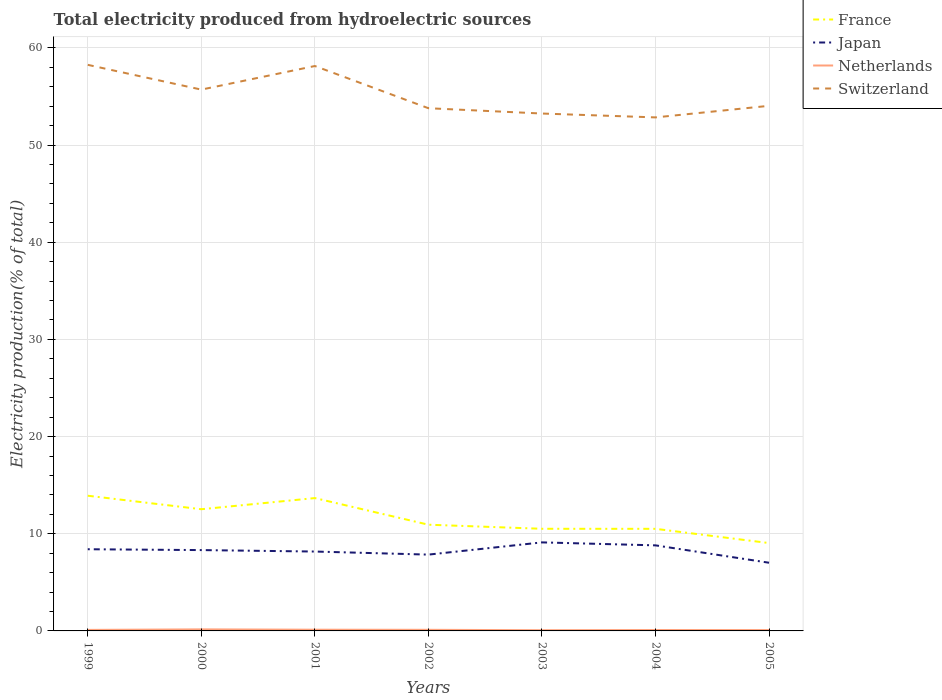Across all years, what is the maximum total electricity produced in Switzerland?
Give a very brief answer. 52.84. In which year was the total electricity produced in France maximum?
Your answer should be very brief. 2005. What is the total total electricity produced in Netherlands in the graph?
Your answer should be compact. 0.07. What is the difference between the highest and the second highest total electricity produced in Switzerland?
Keep it short and to the point. 5.41. What is the difference between the highest and the lowest total electricity produced in Netherlands?
Keep it short and to the point. 3. Is the total electricity produced in Switzerland strictly greater than the total electricity produced in France over the years?
Your response must be concise. No. How many lines are there?
Keep it short and to the point. 4. How many years are there in the graph?
Your response must be concise. 7. Are the values on the major ticks of Y-axis written in scientific E-notation?
Ensure brevity in your answer.  No. Does the graph contain any zero values?
Your response must be concise. No. Does the graph contain grids?
Offer a terse response. Yes. Where does the legend appear in the graph?
Offer a very short reply. Top right. How many legend labels are there?
Offer a very short reply. 4. How are the legend labels stacked?
Provide a short and direct response. Vertical. What is the title of the graph?
Offer a very short reply. Total electricity produced from hydroelectric sources. Does "Europe(developing only)" appear as one of the legend labels in the graph?
Offer a terse response. No. What is the label or title of the Y-axis?
Your response must be concise. Electricity production(% of total). What is the Electricity production(% of total) in France in 1999?
Ensure brevity in your answer.  13.91. What is the Electricity production(% of total) in Japan in 1999?
Provide a succinct answer. 8.41. What is the Electricity production(% of total) in Netherlands in 1999?
Offer a very short reply. 0.1. What is the Electricity production(% of total) in Switzerland in 1999?
Offer a terse response. 58.25. What is the Electricity production(% of total) of France in 2000?
Ensure brevity in your answer.  12.52. What is the Electricity production(% of total) of Japan in 2000?
Offer a terse response. 8.32. What is the Electricity production(% of total) in Netherlands in 2000?
Give a very brief answer. 0.16. What is the Electricity production(% of total) of Switzerland in 2000?
Offer a terse response. 55.7. What is the Electricity production(% of total) of France in 2001?
Ensure brevity in your answer.  13.67. What is the Electricity production(% of total) in Japan in 2001?
Provide a short and direct response. 8.17. What is the Electricity production(% of total) in Netherlands in 2001?
Provide a succinct answer. 0.12. What is the Electricity production(% of total) in Switzerland in 2001?
Your response must be concise. 58.13. What is the Electricity production(% of total) in France in 2002?
Your answer should be compact. 10.93. What is the Electricity production(% of total) of Japan in 2002?
Provide a short and direct response. 7.85. What is the Electricity production(% of total) of Netherlands in 2002?
Your response must be concise. 0.11. What is the Electricity production(% of total) in Switzerland in 2002?
Give a very brief answer. 53.79. What is the Electricity production(% of total) of France in 2003?
Your answer should be compact. 10.51. What is the Electricity production(% of total) in Japan in 2003?
Provide a succinct answer. 9.11. What is the Electricity production(% of total) of Netherlands in 2003?
Give a very brief answer. 0.07. What is the Electricity production(% of total) of Switzerland in 2003?
Provide a short and direct response. 53.24. What is the Electricity production(% of total) in France in 2004?
Make the answer very short. 10.51. What is the Electricity production(% of total) of Japan in 2004?
Your answer should be compact. 8.8. What is the Electricity production(% of total) of Netherlands in 2004?
Provide a short and direct response. 0.09. What is the Electricity production(% of total) of Switzerland in 2004?
Your answer should be very brief. 52.84. What is the Electricity production(% of total) in France in 2005?
Your response must be concise. 9.04. What is the Electricity production(% of total) of Japan in 2005?
Your answer should be very brief. 7.02. What is the Electricity production(% of total) in Netherlands in 2005?
Your response must be concise. 0.09. What is the Electricity production(% of total) of Switzerland in 2005?
Make the answer very short. 54.04. Across all years, what is the maximum Electricity production(% of total) in France?
Your answer should be compact. 13.91. Across all years, what is the maximum Electricity production(% of total) in Japan?
Make the answer very short. 9.11. Across all years, what is the maximum Electricity production(% of total) in Netherlands?
Provide a succinct answer. 0.16. Across all years, what is the maximum Electricity production(% of total) in Switzerland?
Your answer should be very brief. 58.25. Across all years, what is the minimum Electricity production(% of total) in France?
Ensure brevity in your answer.  9.04. Across all years, what is the minimum Electricity production(% of total) of Japan?
Keep it short and to the point. 7.02. Across all years, what is the minimum Electricity production(% of total) of Netherlands?
Your response must be concise. 0.07. Across all years, what is the minimum Electricity production(% of total) of Switzerland?
Offer a terse response. 52.84. What is the total Electricity production(% of total) in France in the graph?
Give a very brief answer. 81.09. What is the total Electricity production(% of total) of Japan in the graph?
Provide a short and direct response. 57.68. What is the total Electricity production(% of total) of Netherlands in the graph?
Offer a very short reply. 0.76. What is the total Electricity production(% of total) of Switzerland in the graph?
Provide a succinct answer. 386. What is the difference between the Electricity production(% of total) in France in 1999 and that in 2000?
Your answer should be compact. 1.39. What is the difference between the Electricity production(% of total) of Japan in 1999 and that in 2000?
Provide a short and direct response. 0.09. What is the difference between the Electricity production(% of total) of Netherlands in 1999 and that in 2000?
Make the answer very short. -0.05. What is the difference between the Electricity production(% of total) of Switzerland in 1999 and that in 2000?
Offer a terse response. 2.55. What is the difference between the Electricity production(% of total) of France in 1999 and that in 2001?
Provide a succinct answer. 0.24. What is the difference between the Electricity production(% of total) of Japan in 1999 and that in 2001?
Ensure brevity in your answer.  0.24. What is the difference between the Electricity production(% of total) of Netherlands in 1999 and that in 2001?
Provide a succinct answer. -0.02. What is the difference between the Electricity production(% of total) of Switzerland in 1999 and that in 2001?
Provide a short and direct response. 0.12. What is the difference between the Electricity production(% of total) in France in 1999 and that in 2002?
Provide a succinct answer. 2.98. What is the difference between the Electricity production(% of total) in Japan in 1999 and that in 2002?
Ensure brevity in your answer.  0.55. What is the difference between the Electricity production(% of total) of Netherlands in 1999 and that in 2002?
Ensure brevity in your answer.  -0.01. What is the difference between the Electricity production(% of total) of Switzerland in 1999 and that in 2002?
Your answer should be compact. 4.46. What is the difference between the Electricity production(% of total) in France in 1999 and that in 2003?
Make the answer very short. 3.4. What is the difference between the Electricity production(% of total) in Japan in 1999 and that in 2003?
Provide a succinct answer. -0.71. What is the difference between the Electricity production(% of total) of Netherlands in 1999 and that in 2003?
Make the answer very short. 0.03. What is the difference between the Electricity production(% of total) of Switzerland in 1999 and that in 2003?
Your answer should be compact. 5.01. What is the difference between the Electricity production(% of total) of France in 1999 and that in 2004?
Your answer should be very brief. 3.41. What is the difference between the Electricity production(% of total) of Japan in 1999 and that in 2004?
Offer a terse response. -0.4. What is the difference between the Electricity production(% of total) of Netherlands in 1999 and that in 2004?
Give a very brief answer. 0.01. What is the difference between the Electricity production(% of total) in Switzerland in 1999 and that in 2004?
Give a very brief answer. 5.41. What is the difference between the Electricity production(% of total) of France in 1999 and that in 2005?
Offer a very short reply. 4.87. What is the difference between the Electricity production(% of total) in Japan in 1999 and that in 2005?
Keep it short and to the point. 1.39. What is the difference between the Electricity production(% of total) of Netherlands in 1999 and that in 2005?
Offer a very short reply. 0.02. What is the difference between the Electricity production(% of total) of Switzerland in 1999 and that in 2005?
Give a very brief answer. 4.22. What is the difference between the Electricity production(% of total) in France in 2000 and that in 2001?
Your answer should be compact. -1.15. What is the difference between the Electricity production(% of total) in Japan in 2000 and that in 2001?
Your answer should be compact. 0.15. What is the difference between the Electricity production(% of total) in Netherlands in 2000 and that in 2001?
Your answer should be compact. 0.03. What is the difference between the Electricity production(% of total) in Switzerland in 2000 and that in 2001?
Ensure brevity in your answer.  -2.43. What is the difference between the Electricity production(% of total) of France in 2000 and that in 2002?
Your answer should be compact. 1.59. What is the difference between the Electricity production(% of total) in Japan in 2000 and that in 2002?
Offer a terse response. 0.46. What is the difference between the Electricity production(% of total) in Netherlands in 2000 and that in 2002?
Your answer should be compact. 0.04. What is the difference between the Electricity production(% of total) in Switzerland in 2000 and that in 2002?
Make the answer very short. 1.91. What is the difference between the Electricity production(% of total) in France in 2000 and that in 2003?
Keep it short and to the point. 2.01. What is the difference between the Electricity production(% of total) in Japan in 2000 and that in 2003?
Offer a very short reply. -0.79. What is the difference between the Electricity production(% of total) of Netherlands in 2000 and that in 2003?
Provide a succinct answer. 0.08. What is the difference between the Electricity production(% of total) in Switzerland in 2000 and that in 2003?
Your response must be concise. 2.46. What is the difference between the Electricity production(% of total) in France in 2000 and that in 2004?
Keep it short and to the point. 2.02. What is the difference between the Electricity production(% of total) in Japan in 2000 and that in 2004?
Provide a short and direct response. -0.49. What is the difference between the Electricity production(% of total) in Netherlands in 2000 and that in 2004?
Your response must be concise. 0.07. What is the difference between the Electricity production(% of total) of Switzerland in 2000 and that in 2004?
Make the answer very short. 2.86. What is the difference between the Electricity production(% of total) of France in 2000 and that in 2005?
Provide a short and direct response. 3.48. What is the difference between the Electricity production(% of total) in Japan in 2000 and that in 2005?
Your response must be concise. 1.3. What is the difference between the Electricity production(% of total) of Netherlands in 2000 and that in 2005?
Ensure brevity in your answer.  0.07. What is the difference between the Electricity production(% of total) of Switzerland in 2000 and that in 2005?
Offer a terse response. 1.67. What is the difference between the Electricity production(% of total) in France in 2001 and that in 2002?
Make the answer very short. 2.74. What is the difference between the Electricity production(% of total) in Japan in 2001 and that in 2002?
Offer a terse response. 0.32. What is the difference between the Electricity production(% of total) in Netherlands in 2001 and that in 2002?
Make the answer very short. 0.01. What is the difference between the Electricity production(% of total) of Switzerland in 2001 and that in 2002?
Your answer should be compact. 4.34. What is the difference between the Electricity production(% of total) of France in 2001 and that in 2003?
Make the answer very short. 3.16. What is the difference between the Electricity production(% of total) of Japan in 2001 and that in 2003?
Offer a terse response. -0.94. What is the difference between the Electricity production(% of total) in Netherlands in 2001 and that in 2003?
Provide a short and direct response. 0.05. What is the difference between the Electricity production(% of total) in Switzerland in 2001 and that in 2003?
Keep it short and to the point. 4.89. What is the difference between the Electricity production(% of total) of France in 2001 and that in 2004?
Keep it short and to the point. 3.16. What is the difference between the Electricity production(% of total) in Japan in 2001 and that in 2004?
Your answer should be very brief. -0.64. What is the difference between the Electricity production(% of total) in Netherlands in 2001 and that in 2004?
Offer a terse response. 0.03. What is the difference between the Electricity production(% of total) of Switzerland in 2001 and that in 2004?
Ensure brevity in your answer.  5.29. What is the difference between the Electricity production(% of total) of France in 2001 and that in 2005?
Give a very brief answer. 4.63. What is the difference between the Electricity production(% of total) of Japan in 2001 and that in 2005?
Offer a very short reply. 1.15. What is the difference between the Electricity production(% of total) in Netherlands in 2001 and that in 2005?
Your answer should be compact. 0.04. What is the difference between the Electricity production(% of total) in Switzerland in 2001 and that in 2005?
Your response must be concise. 4.1. What is the difference between the Electricity production(% of total) in France in 2002 and that in 2003?
Ensure brevity in your answer.  0.42. What is the difference between the Electricity production(% of total) in Japan in 2002 and that in 2003?
Offer a terse response. -1.26. What is the difference between the Electricity production(% of total) in Netherlands in 2002 and that in 2003?
Provide a short and direct response. 0.04. What is the difference between the Electricity production(% of total) in Switzerland in 2002 and that in 2003?
Your answer should be very brief. 0.55. What is the difference between the Electricity production(% of total) of France in 2002 and that in 2004?
Offer a terse response. 0.42. What is the difference between the Electricity production(% of total) of Japan in 2002 and that in 2004?
Provide a short and direct response. -0.95. What is the difference between the Electricity production(% of total) in Netherlands in 2002 and that in 2004?
Make the answer very short. 0.02. What is the difference between the Electricity production(% of total) of Switzerland in 2002 and that in 2004?
Offer a terse response. 0.95. What is the difference between the Electricity production(% of total) in France in 2002 and that in 2005?
Ensure brevity in your answer.  1.89. What is the difference between the Electricity production(% of total) of Japan in 2002 and that in 2005?
Provide a succinct answer. 0.84. What is the difference between the Electricity production(% of total) in Netherlands in 2002 and that in 2005?
Make the answer very short. 0.03. What is the difference between the Electricity production(% of total) in Switzerland in 2002 and that in 2005?
Offer a terse response. -0.25. What is the difference between the Electricity production(% of total) of France in 2003 and that in 2004?
Give a very brief answer. 0. What is the difference between the Electricity production(% of total) in Japan in 2003 and that in 2004?
Ensure brevity in your answer.  0.31. What is the difference between the Electricity production(% of total) in Netherlands in 2003 and that in 2004?
Keep it short and to the point. -0.02. What is the difference between the Electricity production(% of total) in Switzerland in 2003 and that in 2004?
Ensure brevity in your answer.  0.4. What is the difference between the Electricity production(% of total) in France in 2003 and that in 2005?
Ensure brevity in your answer.  1.47. What is the difference between the Electricity production(% of total) in Japan in 2003 and that in 2005?
Provide a short and direct response. 2.09. What is the difference between the Electricity production(% of total) of Netherlands in 2003 and that in 2005?
Offer a terse response. -0.01. What is the difference between the Electricity production(% of total) in Switzerland in 2003 and that in 2005?
Keep it short and to the point. -0.79. What is the difference between the Electricity production(% of total) in France in 2004 and that in 2005?
Your response must be concise. 1.47. What is the difference between the Electricity production(% of total) in Japan in 2004 and that in 2005?
Provide a succinct answer. 1.79. What is the difference between the Electricity production(% of total) of Netherlands in 2004 and that in 2005?
Provide a short and direct response. 0. What is the difference between the Electricity production(% of total) in Switzerland in 2004 and that in 2005?
Provide a short and direct response. -1.19. What is the difference between the Electricity production(% of total) in France in 1999 and the Electricity production(% of total) in Japan in 2000?
Provide a short and direct response. 5.59. What is the difference between the Electricity production(% of total) of France in 1999 and the Electricity production(% of total) of Netherlands in 2000?
Ensure brevity in your answer.  13.75. What is the difference between the Electricity production(% of total) of France in 1999 and the Electricity production(% of total) of Switzerland in 2000?
Ensure brevity in your answer.  -41.79. What is the difference between the Electricity production(% of total) in Japan in 1999 and the Electricity production(% of total) in Netherlands in 2000?
Offer a very short reply. 8.25. What is the difference between the Electricity production(% of total) in Japan in 1999 and the Electricity production(% of total) in Switzerland in 2000?
Offer a very short reply. -47.3. What is the difference between the Electricity production(% of total) in Netherlands in 1999 and the Electricity production(% of total) in Switzerland in 2000?
Keep it short and to the point. -55.6. What is the difference between the Electricity production(% of total) in France in 1999 and the Electricity production(% of total) in Japan in 2001?
Your answer should be compact. 5.74. What is the difference between the Electricity production(% of total) in France in 1999 and the Electricity production(% of total) in Netherlands in 2001?
Ensure brevity in your answer.  13.79. What is the difference between the Electricity production(% of total) in France in 1999 and the Electricity production(% of total) in Switzerland in 2001?
Provide a short and direct response. -44.22. What is the difference between the Electricity production(% of total) of Japan in 1999 and the Electricity production(% of total) of Netherlands in 2001?
Your answer should be very brief. 8.28. What is the difference between the Electricity production(% of total) of Japan in 1999 and the Electricity production(% of total) of Switzerland in 2001?
Make the answer very short. -49.73. What is the difference between the Electricity production(% of total) of Netherlands in 1999 and the Electricity production(% of total) of Switzerland in 2001?
Offer a terse response. -58.03. What is the difference between the Electricity production(% of total) of France in 1999 and the Electricity production(% of total) of Japan in 2002?
Provide a short and direct response. 6.06. What is the difference between the Electricity production(% of total) in France in 1999 and the Electricity production(% of total) in Netherlands in 2002?
Make the answer very short. 13.8. What is the difference between the Electricity production(% of total) of France in 1999 and the Electricity production(% of total) of Switzerland in 2002?
Your response must be concise. -39.88. What is the difference between the Electricity production(% of total) of Japan in 1999 and the Electricity production(% of total) of Netherlands in 2002?
Make the answer very short. 8.29. What is the difference between the Electricity production(% of total) of Japan in 1999 and the Electricity production(% of total) of Switzerland in 2002?
Your answer should be compact. -45.38. What is the difference between the Electricity production(% of total) in Netherlands in 1999 and the Electricity production(% of total) in Switzerland in 2002?
Give a very brief answer. -53.69. What is the difference between the Electricity production(% of total) of France in 1999 and the Electricity production(% of total) of Japan in 2003?
Offer a terse response. 4.8. What is the difference between the Electricity production(% of total) in France in 1999 and the Electricity production(% of total) in Netherlands in 2003?
Keep it short and to the point. 13.84. What is the difference between the Electricity production(% of total) in France in 1999 and the Electricity production(% of total) in Switzerland in 2003?
Offer a terse response. -39.33. What is the difference between the Electricity production(% of total) of Japan in 1999 and the Electricity production(% of total) of Netherlands in 2003?
Give a very brief answer. 8.33. What is the difference between the Electricity production(% of total) of Japan in 1999 and the Electricity production(% of total) of Switzerland in 2003?
Ensure brevity in your answer.  -44.84. What is the difference between the Electricity production(% of total) in Netherlands in 1999 and the Electricity production(% of total) in Switzerland in 2003?
Offer a very short reply. -53.14. What is the difference between the Electricity production(% of total) of France in 1999 and the Electricity production(% of total) of Japan in 2004?
Your answer should be compact. 5.11. What is the difference between the Electricity production(% of total) in France in 1999 and the Electricity production(% of total) in Netherlands in 2004?
Give a very brief answer. 13.82. What is the difference between the Electricity production(% of total) in France in 1999 and the Electricity production(% of total) in Switzerland in 2004?
Give a very brief answer. -38.93. What is the difference between the Electricity production(% of total) in Japan in 1999 and the Electricity production(% of total) in Netherlands in 2004?
Keep it short and to the point. 8.31. What is the difference between the Electricity production(% of total) of Japan in 1999 and the Electricity production(% of total) of Switzerland in 2004?
Provide a short and direct response. -44.44. What is the difference between the Electricity production(% of total) in Netherlands in 1999 and the Electricity production(% of total) in Switzerland in 2004?
Your answer should be very brief. -52.74. What is the difference between the Electricity production(% of total) of France in 1999 and the Electricity production(% of total) of Japan in 2005?
Keep it short and to the point. 6.9. What is the difference between the Electricity production(% of total) of France in 1999 and the Electricity production(% of total) of Netherlands in 2005?
Provide a succinct answer. 13.82. What is the difference between the Electricity production(% of total) of France in 1999 and the Electricity production(% of total) of Switzerland in 2005?
Provide a short and direct response. -40.12. What is the difference between the Electricity production(% of total) in Japan in 1999 and the Electricity production(% of total) in Netherlands in 2005?
Keep it short and to the point. 8.32. What is the difference between the Electricity production(% of total) of Japan in 1999 and the Electricity production(% of total) of Switzerland in 2005?
Offer a very short reply. -45.63. What is the difference between the Electricity production(% of total) of Netherlands in 1999 and the Electricity production(% of total) of Switzerland in 2005?
Ensure brevity in your answer.  -53.93. What is the difference between the Electricity production(% of total) of France in 2000 and the Electricity production(% of total) of Japan in 2001?
Ensure brevity in your answer.  4.35. What is the difference between the Electricity production(% of total) of France in 2000 and the Electricity production(% of total) of Netherlands in 2001?
Ensure brevity in your answer.  12.4. What is the difference between the Electricity production(% of total) of France in 2000 and the Electricity production(% of total) of Switzerland in 2001?
Offer a terse response. -45.61. What is the difference between the Electricity production(% of total) in Japan in 2000 and the Electricity production(% of total) in Netherlands in 2001?
Provide a succinct answer. 8.19. What is the difference between the Electricity production(% of total) of Japan in 2000 and the Electricity production(% of total) of Switzerland in 2001?
Keep it short and to the point. -49.81. What is the difference between the Electricity production(% of total) of Netherlands in 2000 and the Electricity production(% of total) of Switzerland in 2001?
Offer a terse response. -57.97. What is the difference between the Electricity production(% of total) in France in 2000 and the Electricity production(% of total) in Japan in 2002?
Your answer should be very brief. 4.67. What is the difference between the Electricity production(% of total) in France in 2000 and the Electricity production(% of total) in Netherlands in 2002?
Provide a short and direct response. 12.41. What is the difference between the Electricity production(% of total) of France in 2000 and the Electricity production(% of total) of Switzerland in 2002?
Provide a succinct answer. -41.27. What is the difference between the Electricity production(% of total) of Japan in 2000 and the Electricity production(% of total) of Netherlands in 2002?
Your response must be concise. 8.2. What is the difference between the Electricity production(% of total) in Japan in 2000 and the Electricity production(% of total) in Switzerland in 2002?
Keep it short and to the point. -45.47. What is the difference between the Electricity production(% of total) in Netherlands in 2000 and the Electricity production(% of total) in Switzerland in 2002?
Make the answer very short. -53.63. What is the difference between the Electricity production(% of total) in France in 2000 and the Electricity production(% of total) in Japan in 2003?
Ensure brevity in your answer.  3.41. What is the difference between the Electricity production(% of total) in France in 2000 and the Electricity production(% of total) in Netherlands in 2003?
Keep it short and to the point. 12.45. What is the difference between the Electricity production(% of total) of France in 2000 and the Electricity production(% of total) of Switzerland in 2003?
Your response must be concise. -40.72. What is the difference between the Electricity production(% of total) in Japan in 2000 and the Electricity production(% of total) in Netherlands in 2003?
Ensure brevity in your answer.  8.24. What is the difference between the Electricity production(% of total) in Japan in 2000 and the Electricity production(% of total) in Switzerland in 2003?
Make the answer very short. -44.92. What is the difference between the Electricity production(% of total) of Netherlands in 2000 and the Electricity production(% of total) of Switzerland in 2003?
Your answer should be compact. -53.08. What is the difference between the Electricity production(% of total) in France in 2000 and the Electricity production(% of total) in Japan in 2004?
Ensure brevity in your answer.  3.72. What is the difference between the Electricity production(% of total) in France in 2000 and the Electricity production(% of total) in Netherlands in 2004?
Your answer should be compact. 12.43. What is the difference between the Electricity production(% of total) of France in 2000 and the Electricity production(% of total) of Switzerland in 2004?
Your answer should be very brief. -40.32. What is the difference between the Electricity production(% of total) of Japan in 2000 and the Electricity production(% of total) of Netherlands in 2004?
Offer a terse response. 8.23. What is the difference between the Electricity production(% of total) in Japan in 2000 and the Electricity production(% of total) in Switzerland in 2004?
Your answer should be compact. -44.53. What is the difference between the Electricity production(% of total) of Netherlands in 2000 and the Electricity production(% of total) of Switzerland in 2004?
Make the answer very short. -52.69. What is the difference between the Electricity production(% of total) of France in 2000 and the Electricity production(% of total) of Japan in 2005?
Provide a succinct answer. 5.51. What is the difference between the Electricity production(% of total) in France in 2000 and the Electricity production(% of total) in Netherlands in 2005?
Provide a succinct answer. 12.44. What is the difference between the Electricity production(% of total) of France in 2000 and the Electricity production(% of total) of Switzerland in 2005?
Your answer should be very brief. -41.51. What is the difference between the Electricity production(% of total) in Japan in 2000 and the Electricity production(% of total) in Netherlands in 2005?
Your response must be concise. 8.23. What is the difference between the Electricity production(% of total) in Japan in 2000 and the Electricity production(% of total) in Switzerland in 2005?
Keep it short and to the point. -45.72. What is the difference between the Electricity production(% of total) in Netherlands in 2000 and the Electricity production(% of total) in Switzerland in 2005?
Provide a succinct answer. -53.88. What is the difference between the Electricity production(% of total) of France in 2001 and the Electricity production(% of total) of Japan in 2002?
Keep it short and to the point. 5.82. What is the difference between the Electricity production(% of total) of France in 2001 and the Electricity production(% of total) of Netherlands in 2002?
Make the answer very short. 13.56. What is the difference between the Electricity production(% of total) in France in 2001 and the Electricity production(% of total) in Switzerland in 2002?
Give a very brief answer. -40.12. What is the difference between the Electricity production(% of total) in Japan in 2001 and the Electricity production(% of total) in Netherlands in 2002?
Offer a very short reply. 8.05. What is the difference between the Electricity production(% of total) of Japan in 2001 and the Electricity production(% of total) of Switzerland in 2002?
Your answer should be compact. -45.62. What is the difference between the Electricity production(% of total) of Netherlands in 2001 and the Electricity production(% of total) of Switzerland in 2002?
Provide a succinct answer. -53.66. What is the difference between the Electricity production(% of total) in France in 2001 and the Electricity production(% of total) in Japan in 2003?
Your answer should be compact. 4.56. What is the difference between the Electricity production(% of total) of France in 2001 and the Electricity production(% of total) of Netherlands in 2003?
Ensure brevity in your answer.  13.6. What is the difference between the Electricity production(% of total) in France in 2001 and the Electricity production(% of total) in Switzerland in 2003?
Your answer should be very brief. -39.57. What is the difference between the Electricity production(% of total) of Japan in 2001 and the Electricity production(% of total) of Netherlands in 2003?
Keep it short and to the point. 8.09. What is the difference between the Electricity production(% of total) of Japan in 2001 and the Electricity production(% of total) of Switzerland in 2003?
Make the answer very short. -45.07. What is the difference between the Electricity production(% of total) in Netherlands in 2001 and the Electricity production(% of total) in Switzerland in 2003?
Offer a very short reply. -53.12. What is the difference between the Electricity production(% of total) in France in 2001 and the Electricity production(% of total) in Japan in 2004?
Give a very brief answer. 4.87. What is the difference between the Electricity production(% of total) in France in 2001 and the Electricity production(% of total) in Netherlands in 2004?
Your response must be concise. 13.58. What is the difference between the Electricity production(% of total) in France in 2001 and the Electricity production(% of total) in Switzerland in 2004?
Your answer should be very brief. -39.17. What is the difference between the Electricity production(% of total) in Japan in 2001 and the Electricity production(% of total) in Netherlands in 2004?
Offer a very short reply. 8.08. What is the difference between the Electricity production(% of total) of Japan in 2001 and the Electricity production(% of total) of Switzerland in 2004?
Keep it short and to the point. -44.68. What is the difference between the Electricity production(% of total) of Netherlands in 2001 and the Electricity production(% of total) of Switzerland in 2004?
Give a very brief answer. -52.72. What is the difference between the Electricity production(% of total) in France in 2001 and the Electricity production(% of total) in Japan in 2005?
Ensure brevity in your answer.  6.65. What is the difference between the Electricity production(% of total) of France in 2001 and the Electricity production(% of total) of Netherlands in 2005?
Ensure brevity in your answer.  13.58. What is the difference between the Electricity production(% of total) in France in 2001 and the Electricity production(% of total) in Switzerland in 2005?
Your answer should be very brief. -40.37. What is the difference between the Electricity production(% of total) in Japan in 2001 and the Electricity production(% of total) in Netherlands in 2005?
Provide a succinct answer. 8.08. What is the difference between the Electricity production(% of total) of Japan in 2001 and the Electricity production(% of total) of Switzerland in 2005?
Your answer should be very brief. -45.87. What is the difference between the Electricity production(% of total) in Netherlands in 2001 and the Electricity production(% of total) in Switzerland in 2005?
Provide a succinct answer. -53.91. What is the difference between the Electricity production(% of total) of France in 2002 and the Electricity production(% of total) of Japan in 2003?
Give a very brief answer. 1.82. What is the difference between the Electricity production(% of total) of France in 2002 and the Electricity production(% of total) of Netherlands in 2003?
Provide a short and direct response. 10.86. What is the difference between the Electricity production(% of total) in France in 2002 and the Electricity production(% of total) in Switzerland in 2003?
Your response must be concise. -42.31. What is the difference between the Electricity production(% of total) in Japan in 2002 and the Electricity production(% of total) in Netherlands in 2003?
Offer a terse response. 7.78. What is the difference between the Electricity production(% of total) of Japan in 2002 and the Electricity production(% of total) of Switzerland in 2003?
Keep it short and to the point. -45.39. What is the difference between the Electricity production(% of total) of Netherlands in 2002 and the Electricity production(% of total) of Switzerland in 2003?
Your response must be concise. -53.13. What is the difference between the Electricity production(% of total) of France in 2002 and the Electricity production(% of total) of Japan in 2004?
Give a very brief answer. 2.13. What is the difference between the Electricity production(% of total) of France in 2002 and the Electricity production(% of total) of Netherlands in 2004?
Offer a very short reply. 10.84. What is the difference between the Electricity production(% of total) in France in 2002 and the Electricity production(% of total) in Switzerland in 2004?
Your response must be concise. -41.91. What is the difference between the Electricity production(% of total) of Japan in 2002 and the Electricity production(% of total) of Netherlands in 2004?
Offer a very short reply. 7.76. What is the difference between the Electricity production(% of total) in Japan in 2002 and the Electricity production(% of total) in Switzerland in 2004?
Your answer should be compact. -44.99. What is the difference between the Electricity production(% of total) of Netherlands in 2002 and the Electricity production(% of total) of Switzerland in 2004?
Provide a short and direct response. -52.73. What is the difference between the Electricity production(% of total) in France in 2002 and the Electricity production(% of total) in Japan in 2005?
Make the answer very short. 3.91. What is the difference between the Electricity production(% of total) in France in 2002 and the Electricity production(% of total) in Netherlands in 2005?
Give a very brief answer. 10.84. What is the difference between the Electricity production(% of total) of France in 2002 and the Electricity production(% of total) of Switzerland in 2005?
Your answer should be compact. -43.11. What is the difference between the Electricity production(% of total) in Japan in 2002 and the Electricity production(% of total) in Netherlands in 2005?
Provide a succinct answer. 7.77. What is the difference between the Electricity production(% of total) in Japan in 2002 and the Electricity production(% of total) in Switzerland in 2005?
Make the answer very short. -46.18. What is the difference between the Electricity production(% of total) in Netherlands in 2002 and the Electricity production(% of total) in Switzerland in 2005?
Your answer should be very brief. -53.92. What is the difference between the Electricity production(% of total) in France in 2003 and the Electricity production(% of total) in Japan in 2004?
Provide a succinct answer. 1.71. What is the difference between the Electricity production(% of total) of France in 2003 and the Electricity production(% of total) of Netherlands in 2004?
Keep it short and to the point. 10.42. What is the difference between the Electricity production(% of total) in France in 2003 and the Electricity production(% of total) in Switzerland in 2004?
Make the answer very short. -42.33. What is the difference between the Electricity production(% of total) of Japan in 2003 and the Electricity production(% of total) of Netherlands in 2004?
Provide a succinct answer. 9.02. What is the difference between the Electricity production(% of total) of Japan in 2003 and the Electricity production(% of total) of Switzerland in 2004?
Provide a succinct answer. -43.73. What is the difference between the Electricity production(% of total) of Netherlands in 2003 and the Electricity production(% of total) of Switzerland in 2004?
Make the answer very short. -52.77. What is the difference between the Electricity production(% of total) in France in 2003 and the Electricity production(% of total) in Japan in 2005?
Offer a terse response. 3.49. What is the difference between the Electricity production(% of total) in France in 2003 and the Electricity production(% of total) in Netherlands in 2005?
Your answer should be compact. 10.42. What is the difference between the Electricity production(% of total) of France in 2003 and the Electricity production(% of total) of Switzerland in 2005?
Provide a succinct answer. -43.53. What is the difference between the Electricity production(% of total) in Japan in 2003 and the Electricity production(% of total) in Netherlands in 2005?
Offer a terse response. 9.02. What is the difference between the Electricity production(% of total) in Japan in 2003 and the Electricity production(% of total) in Switzerland in 2005?
Offer a terse response. -44.93. What is the difference between the Electricity production(% of total) in Netherlands in 2003 and the Electricity production(% of total) in Switzerland in 2005?
Offer a very short reply. -53.96. What is the difference between the Electricity production(% of total) of France in 2004 and the Electricity production(% of total) of Japan in 2005?
Provide a succinct answer. 3.49. What is the difference between the Electricity production(% of total) in France in 2004 and the Electricity production(% of total) in Netherlands in 2005?
Your response must be concise. 10.42. What is the difference between the Electricity production(% of total) in France in 2004 and the Electricity production(% of total) in Switzerland in 2005?
Give a very brief answer. -43.53. What is the difference between the Electricity production(% of total) of Japan in 2004 and the Electricity production(% of total) of Netherlands in 2005?
Your response must be concise. 8.72. What is the difference between the Electricity production(% of total) in Japan in 2004 and the Electricity production(% of total) in Switzerland in 2005?
Give a very brief answer. -45.23. What is the difference between the Electricity production(% of total) of Netherlands in 2004 and the Electricity production(% of total) of Switzerland in 2005?
Keep it short and to the point. -53.94. What is the average Electricity production(% of total) in France per year?
Make the answer very short. 11.58. What is the average Electricity production(% of total) in Japan per year?
Make the answer very short. 8.24. What is the average Electricity production(% of total) in Netherlands per year?
Your response must be concise. 0.11. What is the average Electricity production(% of total) in Switzerland per year?
Give a very brief answer. 55.14. In the year 1999, what is the difference between the Electricity production(% of total) of France and Electricity production(% of total) of Japan?
Offer a very short reply. 5.51. In the year 1999, what is the difference between the Electricity production(% of total) of France and Electricity production(% of total) of Netherlands?
Ensure brevity in your answer.  13.81. In the year 1999, what is the difference between the Electricity production(% of total) of France and Electricity production(% of total) of Switzerland?
Provide a succinct answer. -44.34. In the year 1999, what is the difference between the Electricity production(% of total) in Japan and Electricity production(% of total) in Netherlands?
Provide a succinct answer. 8.3. In the year 1999, what is the difference between the Electricity production(% of total) in Japan and Electricity production(% of total) in Switzerland?
Offer a very short reply. -49.85. In the year 1999, what is the difference between the Electricity production(% of total) in Netherlands and Electricity production(% of total) in Switzerland?
Keep it short and to the point. -58.15. In the year 2000, what is the difference between the Electricity production(% of total) of France and Electricity production(% of total) of Japan?
Give a very brief answer. 4.21. In the year 2000, what is the difference between the Electricity production(% of total) of France and Electricity production(% of total) of Netherlands?
Your response must be concise. 12.36. In the year 2000, what is the difference between the Electricity production(% of total) in France and Electricity production(% of total) in Switzerland?
Your response must be concise. -43.18. In the year 2000, what is the difference between the Electricity production(% of total) in Japan and Electricity production(% of total) in Netherlands?
Your answer should be compact. 8.16. In the year 2000, what is the difference between the Electricity production(% of total) in Japan and Electricity production(% of total) in Switzerland?
Offer a terse response. -47.39. In the year 2000, what is the difference between the Electricity production(% of total) of Netherlands and Electricity production(% of total) of Switzerland?
Keep it short and to the point. -55.55. In the year 2001, what is the difference between the Electricity production(% of total) of France and Electricity production(% of total) of Japan?
Keep it short and to the point. 5.5. In the year 2001, what is the difference between the Electricity production(% of total) of France and Electricity production(% of total) of Netherlands?
Offer a terse response. 13.55. In the year 2001, what is the difference between the Electricity production(% of total) in France and Electricity production(% of total) in Switzerland?
Your answer should be very brief. -44.46. In the year 2001, what is the difference between the Electricity production(% of total) in Japan and Electricity production(% of total) in Netherlands?
Give a very brief answer. 8.04. In the year 2001, what is the difference between the Electricity production(% of total) in Japan and Electricity production(% of total) in Switzerland?
Make the answer very short. -49.96. In the year 2001, what is the difference between the Electricity production(% of total) in Netherlands and Electricity production(% of total) in Switzerland?
Make the answer very short. -58.01. In the year 2002, what is the difference between the Electricity production(% of total) in France and Electricity production(% of total) in Japan?
Your answer should be very brief. 3.08. In the year 2002, what is the difference between the Electricity production(% of total) in France and Electricity production(% of total) in Netherlands?
Provide a succinct answer. 10.82. In the year 2002, what is the difference between the Electricity production(% of total) in France and Electricity production(% of total) in Switzerland?
Make the answer very short. -42.86. In the year 2002, what is the difference between the Electricity production(% of total) in Japan and Electricity production(% of total) in Netherlands?
Keep it short and to the point. 7.74. In the year 2002, what is the difference between the Electricity production(% of total) in Japan and Electricity production(% of total) in Switzerland?
Provide a succinct answer. -45.94. In the year 2002, what is the difference between the Electricity production(% of total) of Netherlands and Electricity production(% of total) of Switzerland?
Offer a very short reply. -53.68. In the year 2003, what is the difference between the Electricity production(% of total) in France and Electricity production(% of total) in Netherlands?
Offer a terse response. 10.44. In the year 2003, what is the difference between the Electricity production(% of total) in France and Electricity production(% of total) in Switzerland?
Make the answer very short. -42.73. In the year 2003, what is the difference between the Electricity production(% of total) of Japan and Electricity production(% of total) of Netherlands?
Offer a very short reply. 9.04. In the year 2003, what is the difference between the Electricity production(% of total) of Japan and Electricity production(% of total) of Switzerland?
Make the answer very short. -44.13. In the year 2003, what is the difference between the Electricity production(% of total) of Netherlands and Electricity production(% of total) of Switzerland?
Provide a short and direct response. -53.17. In the year 2004, what is the difference between the Electricity production(% of total) of France and Electricity production(% of total) of Japan?
Your response must be concise. 1.7. In the year 2004, what is the difference between the Electricity production(% of total) in France and Electricity production(% of total) in Netherlands?
Your answer should be compact. 10.41. In the year 2004, what is the difference between the Electricity production(% of total) of France and Electricity production(% of total) of Switzerland?
Make the answer very short. -42.34. In the year 2004, what is the difference between the Electricity production(% of total) in Japan and Electricity production(% of total) in Netherlands?
Keep it short and to the point. 8.71. In the year 2004, what is the difference between the Electricity production(% of total) in Japan and Electricity production(% of total) in Switzerland?
Keep it short and to the point. -44.04. In the year 2004, what is the difference between the Electricity production(% of total) of Netherlands and Electricity production(% of total) of Switzerland?
Offer a terse response. -52.75. In the year 2005, what is the difference between the Electricity production(% of total) of France and Electricity production(% of total) of Japan?
Provide a short and direct response. 2.03. In the year 2005, what is the difference between the Electricity production(% of total) of France and Electricity production(% of total) of Netherlands?
Give a very brief answer. 8.95. In the year 2005, what is the difference between the Electricity production(% of total) of France and Electricity production(% of total) of Switzerland?
Make the answer very short. -45. In the year 2005, what is the difference between the Electricity production(% of total) of Japan and Electricity production(% of total) of Netherlands?
Keep it short and to the point. 6.93. In the year 2005, what is the difference between the Electricity production(% of total) in Japan and Electricity production(% of total) in Switzerland?
Your answer should be compact. -47.02. In the year 2005, what is the difference between the Electricity production(% of total) in Netherlands and Electricity production(% of total) in Switzerland?
Provide a succinct answer. -53.95. What is the ratio of the Electricity production(% of total) in France in 1999 to that in 2000?
Provide a short and direct response. 1.11. What is the ratio of the Electricity production(% of total) of Japan in 1999 to that in 2000?
Offer a very short reply. 1.01. What is the ratio of the Electricity production(% of total) of Netherlands in 1999 to that in 2000?
Your answer should be very brief. 0.66. What is the ratio of the Electricity production(% of total) in Switzerland in 1999 to that in 2000?
Ensure brevity in your answer.  1.05. What is the ratio of the Electricity production(% of total) in France in 1999 to that in 2001?
Give a very brief answer. 1.02. What is the ratio of the Electricity production(% of total) in Japan in 1999 to that in 2001?
Make the answer very short. 1.03. What is the ratio of the Electricity production(% of total) in Netherlands in 1999 to that in 2001?
Ensure brevity in your answer.  0.83. What is the ratio of the Electricity production(% of total) of Switzerland in 1999 to that in 2001?
Provide a short and direct response. 1. What is the ratio of the Electricity production(% of total) of France in 1999 to that in 2002?
Provide a short and direct response. 1.27. What is the ratio of the Electricity production(% of total) in Japan in 1999 to that in 2002?
Your answer should be very brief. 1.07. What is the ratio of the Electricity production(% of total) in Netherlands in 1999 to that in 2002?
Keep it short and to the point. 0.91. What is the ratio of the Electricity production(% of total) in Switzerland in 1999 to that in 2002?
Offer a very short reply. 1.08. What is the ratio of the Electricity production(% of total) in France in 1999 to that in 2003?
Provide a short and direct response. 1.32. What is the ratio of the Electricity production(% of total) in Japan in 1999 to that in 2003?
Your answer should be compact. 0.92. What is the ratio of the Electricity production(% of total) of Netherlands in 1999 to that in 2003?
Your response must be concise. 1.4. What is the ratio of the Electricity production(% of total) of Switzerland in 1999 to that in 2003?
Provide a short and direct response. 1.09. What is the ratio of the Electricity production(% of total) of France in 1999 to that in 2004?
Offer a terse response. 1.32. What is the ratio of the Electricity production(% of total) in Japan in 1999 to that in 2004?
Provide a short and direct response. 0.95. What is the ratio of the Electricity production(% of total) in Netherlands in 1999 to that in 2004?
Ensure brevity in your answer.  1.12. What is the ratio of the Electricity production(% of total) in Switzerland in 1999 to that in 2004?
Make the answer very short. 1.1. What is the ratio of the Electricity production(% of total) in France in 1999 to that in 2005?
Offer a terse response. 1.54. What is the ratio of the Electricity production(% of total) in Japan in 1999 to that in 2005?
Provide a short and direct response. 1.2. What is the ratio of the Electricity production(% of total) of Netherlands in 1999 to that in 2005?
Keep it short and to the point. 1.18. What is the ratio of the Electricity production(% of total) in Switzerland in 1999 to that in 2005?
Your answer should be compact. 1.08. What is the ratio of the Electricity production(% of total) of France in 2000 to that in 2001?
Offer a very short reply. 0.92. What is the ratio of the Electricity production(% of total) of Japan in 2000 to that in 2001?
Ensure brevity in your answer.  1.02. What is the ratio of the Electricity production(% of total) of Netherlands in 2000 to that in 2001?
Offer a terse response. 1.27. What is the ratio of the Electricity production(% of total) in Switzerland in 2000 to that in 2001?
Make the answer very short. 0.96. What is the ratio of the Electricity production(% of total) of France in 2000 to that in 2002?
Keep it short and to the point. 1.15. What is the ratio of the Electricity production(% of total) of Japan in 2000 to that in 2002?
Your answer should be compact. 1.06. What is the ratio of the Electricity production(% of total) of Netherlands in 2000 to that in 2002?
Your answer should be very brief. 1.38. What is the ratio of the Electricity production(% of total) of Switzerland in 2000 to that in 2002?
Provide a short and direct response. 1.04. What is the ratio of the Electricity production(% of total) in France in 2000 to that in 2003?
Provide a succinct answer. 1.19. What is the ratio of the Electricity production(% of total) of Netherlands in 2000 to that in 2003?
Your response must be concise. 2.13. What is the ratio of the Electricity production(% of total) of Switzerland in 2000 to that in 2003?
Provide a succinct answer. 1.05. What is the ratio of the Electricity production(% of total) of France in 2000 to that in 2004?
Provide a short and direct response. 1.19. What is the ratio of the Electricity production(% of total) of Japan in 2000 to that in 2004?
Ensure brevity in your answer.  0.94. What is the ratio of the Electricity production(% of total) of Netherlands in 2000 to that in 2004?
Ensure brevity in your answer.  1.71. What is the ratio of the Electricity production(% of total) of Switzerland in 2000 to that in 2004?
Your answer should be very brief. 1.05. What is the ratio of the Electricity production(% of total) of France in 2000 to that in 2005?
Offer a very short reply. 1.39. What is the ratio of the Electricity production(% of total) of Japan in 2000 to that in 2005?
Offer a very short reply. 1.19. What is the ratio of the Electricity production(% of total) in Netherlands in 2000 to that in 2005?
Offer a terse response. 1.8. What is the ratio of the Electricity production(% of total) in Switzerland in 2000 to that in 2005?
Your answer should be compact. 1.03. What is the ratio of the Electricity production(% of total) in France in 2001 to that in 2002?
Provide a short and direct response. 1.25. What is the ratio of the Electricity production(% of total) in Japan in 2001 to that in 2002?
Offer a very short reply. 1.04. What is the ratio of the Electricity production(% of total) of Netherlands in 2001 to that in 2002?
Your answer should be compact. 1.09. What is the ratio of the Electricity production(% of total) of Switzerland in 2001 to that in 2002?
Provide a succinct answer. 1.08. What is the ratio of the Electricity production(% of total) in France in 2001 to that in 2003?
Give a very brief answer. 1.3. What is the ratio of the Electricity production(% of total) of Japan in 2001 to that in 2003?
Offer a very short reply. 0.9. What is the ratio of the Electricity production(% of total) in Netherlands in 2001 to that in 2003?
Offer a terse response. 1.68. What is the ratio of the Electricity production(% of total) in Switzerland in 2001 to that in 2003?
Offer a very short reply. 1.09. What is the ratio of the Electricity production(% of total) of France in 2001 to that in 2004?
Provide a short and direct response. 1.3. What is the ratio of the Electricity production(% of total) of Japan in 2001 to that in 2004?
Offer a very short reply. 0.93. What is the ratio of the Electricity production(% of total) in Netherlands in 2001 to that in 2004?
Your response must be concise. 1.35. What is the ratio of the Electricity production(% of total) in Switzerland in 2001 to that in 2004?
Offer a terse response. 1.1. What is the ratio of the Electricity production(% of total) in France in 2001 to that in 2005?
Provide a short and direct response. 1.51. What is the ratio of the Electricity production(% of total) of Japan in 2001 to that in 2005?
Make the answer very short. 1.16. What is the ratio of the Electricity production(% of total) in Netherlands in 2001 to that in 2005?
Your answer should be compact. 1.42. What is the ratio of the Electricity production(% of total) of Switzerland in 2001 to that in 2005?
Provide a short and direct response. 1.08. What is the ratio of the Electricity production(% of total) in France in 2002 to that in 2003?
Provide a short and direct response. 1.04. What is the ratio of the Electricity production(% of total) in Japan in 2002 to that in 2003?
Keep it short and to the point. 0.86. What is the ratio of the Electricity production(% of total) in Netherlands in 2002 to that in 2003?
Provide a succinct answer. 1.54. What is the ratio of the Electricity production(% of total) of Switzerland in 2002 to that in 2003?
Provide a short and direct response. 1.01. What is the ratio of the Electricity production(% of total) of France in 2002 to that in 2004?
Make the answer very short. 1.04. What is the ratio of the Electricity production(% of total) of Japan in 2002 to that in 2004?
Provide a succinct answer. 0.89. What is the ratio of the Electricity production(% of total) of Netherlands in 2002 to that in 2004?
Your response must be concise. 1.24. What is the ratio of the Electricity production(% of total) of Switzerland in 2002 to that in 2004?
Your answer should be compact. 1.02. What is the ratio of the Electricity production(% of total) of France in 2002 to that in 2005?
Provide a succinct answer. 1.21. What is the ratio of the Electricity production(% of total) in Japan in 2002 to that in 2005?
Your response must be concise. 1.12. What is the ratio of the Electricity production(% of total) in Netherlands in 2002 to that in 2005?
Keep it short and to the point. 1.31. What is the ratio of the Electricity production(% of total) in Switzerland in 2002 to that in 2005?
Provide a succinct answer. 1. What is the ratio of the Electricity production(% of total) in France in 2003 to that in 2004?
Keep it short and to the point. 1. What is the ratio of the Electricity production(% of total) in Japan in 2003 to that in 2004?
Ensure brevity in your answer.  1.03. What is the ratio of the Electricity production(% of total) of Netherlands in 2003 to that in 2004?
Provide a short and direct response. 0.8. What is the ratio of the Electricity production(% of total) of Switzerland in 2003 to that in 2004?
Give a very brief answer. 1.01. What is the ratio of the Electricity production(% of total) in France in 2003 to that in 2005?
Offer a very short reply. 1.16. What is the ratio of the Electricity production(% of total) in Japan in 2003 to that in 2005?
Keep it short and to the point. 1.3. What is the ratio of the Electricity production(% of total) in Netherlands in 2003 to that in 2005?
Make the answer very short. 0.85. What is the ratio of the Electricity production(% of total) in France in 2004 to that in 2005?
Ensure brevity in your answer.  1.16. What is the ratio of the Electricity production(% of total) in Japan in 2004 to that in 2005?
Provide a short and direct response. 1.25. What is the ratio of the Electricity production(% of total) of Netherlands in 2004 to that in 2005?
Offer a terse response. 1.06. What is the ratio of the Electricity production(% of total) in Switzerland in 2004 to that in 2005?
Ensure brevity in your answer.  0.98. What is the difference between the highest and the second highest Electricity production(% of total) in France?
Offer a terse response. 0.24. What is the difference between the highest and the second highest Electricity production(% of total) in Japan?
Your response must be concise. 0.31. What is the difference between the highest and the second highest Electricity production(% of total) in Netherlands?
Your answer should be very brief. 0.03. What is the difference between the highest and the second highest Electricity production(% of total) in Switzerland?
Offer a very short reply. 0.12. What is the difference between the highest and the lowest Electricity production(% of total) of France?
Provide a succinct answer. 4.87. What is the difference between the highest and the lowest Electricity production(% of total) in Japan?
Offer a very short reply. 2.09. What is the difference between the highest and the lowest Electricity production(% of total) in Netherlands?
Make the answer very short. 0.08. What is the difference between the highest and the lowest Electricity production(% of total) of Switzerland?
Your answer should be compact. 5.41. 